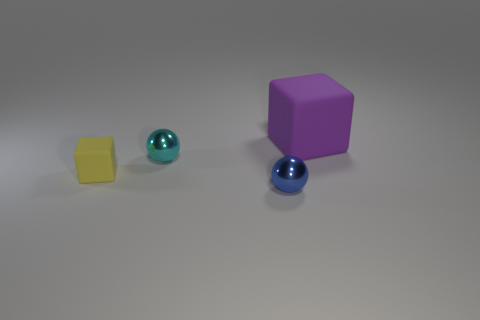There is a object that is in front of the tiny yellow rubber object; is it the same size as the matte cube left of the cyan shiny ball?
Give a very brief answer. Yes. What number of spheres are objects or yellow matte things?
Ensure brevity in your answer.  2. Are any small yellow things visible?
Your answer should be compact. Yes. How many things are tiny shiny balls that are behind the small blue metallic ball or blue spheres?
Offer a very short reply. 2. What number of small blue things are right of the rubber object that is on the left side of the rubber block behind the yellow rubber cube?
Give a very brief answer. 1. Is there anything else that is the same size as the purple matte object?
Provide a succinct answer. No. The matte thing to the left of the tiny cyan ball on the left side of the matte thing that is to the right of the blue sphere is what shape?
Provide a succinct answer. Cube. How many other objects are the same color as the large thing?
Offer a very short reply. 0. There is a rubber thing that is to the right of the thing that is in front of the yellow object; what shape is it?
Provide a short and direct response. Cube. There is a small yellow matte thing; what number of cubes are to the left of it?
Offer a very short reply. 0. 